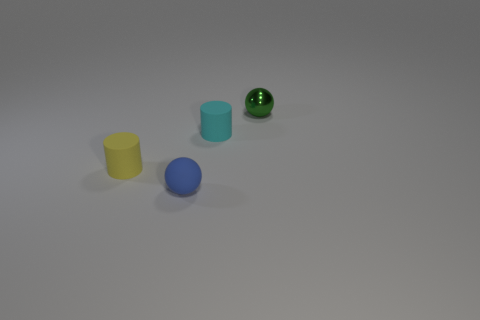What number of cyan objects are either rubber spheres or big cubes? 0 